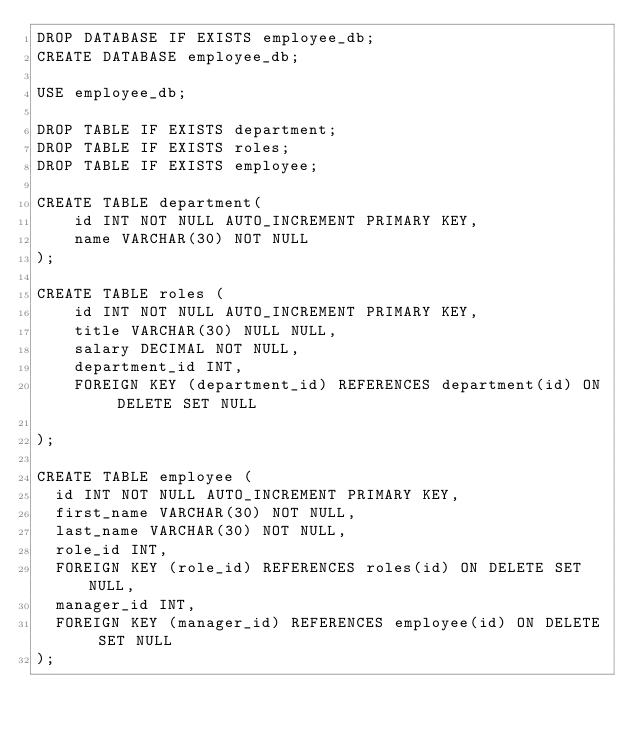Convert code to text. <code><loc_0><loc_0><loc_500><loc_500><_SQL_>DROP DATABASE IF EXISTS employee_db;
CREATE DATABASE employee_db;

USE employee_db;

DROP TABLE IF EXISTS department;
DROP TABLE IF EXISTS roles;
DROP TABLE IF EXISTS employee;

CREATE TABLE department(
    id INT NOT NULL AUTO_INCREMENT PRIMARY KEY,
    name VARCHAR(30) NOT NULL
);

CREATE TABLE roles (
    id INT NOT NULL AUTO_INCREMENT PRIMARY KEY,
    title VARCHAR(30) NULL NULL,
    salary DECIMAL NOT NULL,
    department_id INT,
    FOREIGN KEY (department_id) REFERENCES department(id) ON DELETE SET NULL

);

CREATE TABLE employee (
  id INT NOT NULL AUTO_INCREMENT PRIMARY KEY,
  first_name VARCHAR(30) NOT NULL,
  last_name VARCHAR(30) NOT NULL,
  role_id INT,
  FOREIGN KEY (role_id) REFERENCES roles(id) ON DELETE SET NULL,
  manager_id INT,
  FOREIGN KEY (manager_id) REFERENCES employee(id) ON DELETE SET NULL
);

</code> 